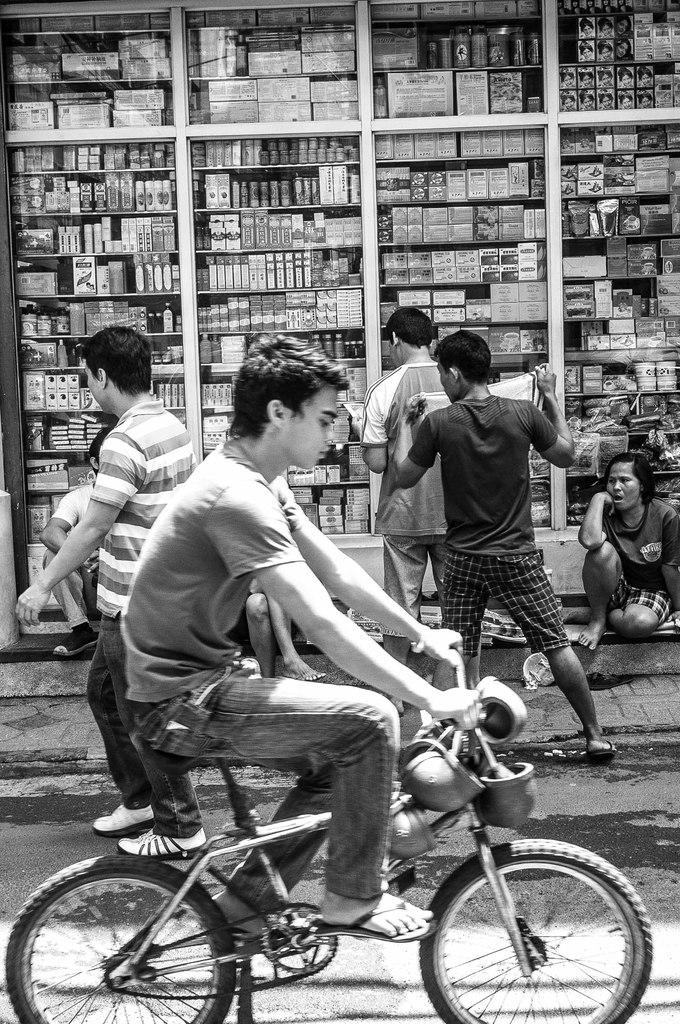What is the color scheme of the image? The image is black and white. What is the man in the image doing? The man is riding a bicycle in the image. What can be seen behind the man? There is a group of people standing on the road behind the man. What is present on the shelf in the image? There are multiple items on the shelf in the image. What type of food is the man eating while riding the bicycle in the image? There is no food present in the image, and the man is not shown eating anything while riding the bicycle. What level of expertise does the man have in riding a bicycle, as indicated by the image? The image does not provide any information about the man's level of expertise in riding a bicycle. 